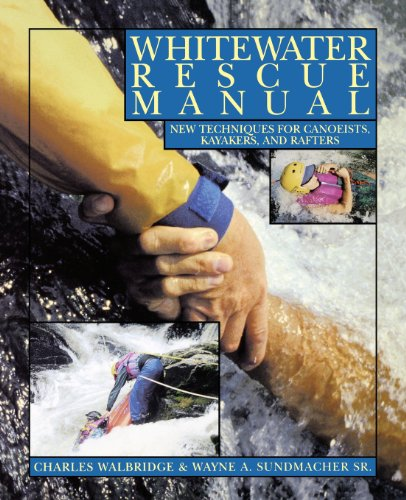What type of book is this? This is a practical manual in the 'Sports & Outdoors' category, specifically targeted toward those interested in canoeing, kayaking, and rafting, focusing on safety and rescue techniques. 